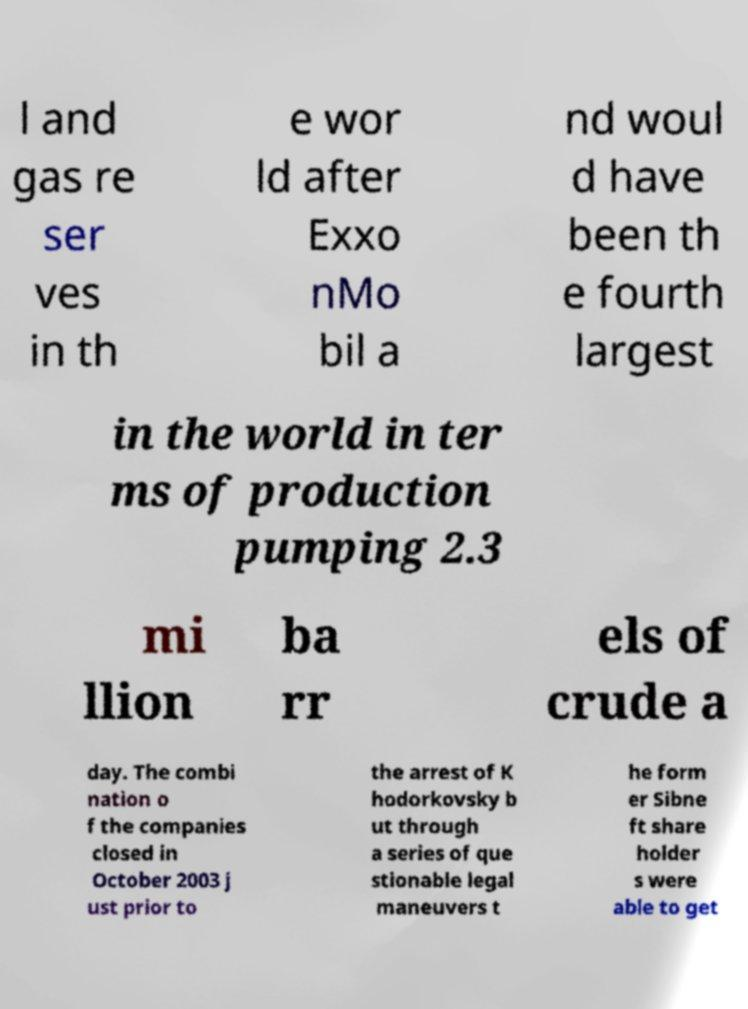For documentation purposes, I need the text within this image transcribed. Could you provide that? l and gas re ser ves in th e wor ld after Exxo nMo bil a nd woul d have been th e fourth largest in the world in ter ms of production pumping 2.3 mi llion ba rr els of crude a day. The combi nation o f the companies closed in October 2003 j ust prior to the arrest of K hodorkovsky b ut through a series of que stionable legal maneuvers t he form er Sibne ft share holder s were able to get 